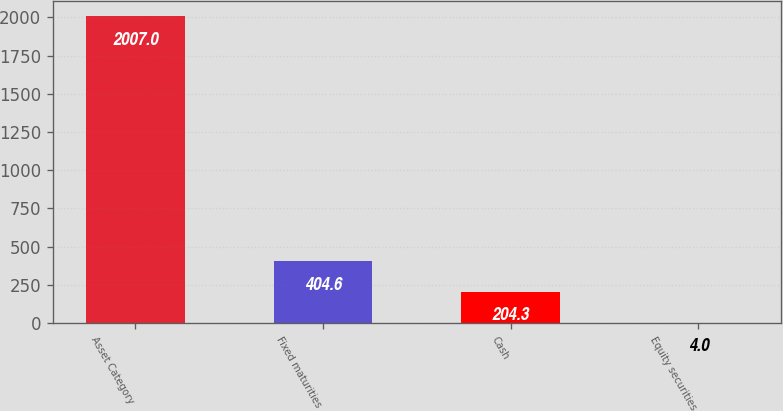Convert chart to OTSL. <chart><loc_0><loc_0><loc_500><loc_500><bar_chart><fcel>Asset Category<fcel>Fixed maturities<fcel>Cash<fcel>Equity securities<nl><fcel>2007<fcel>404.6<fcel>204.3<fcel>4<nl></chart> 